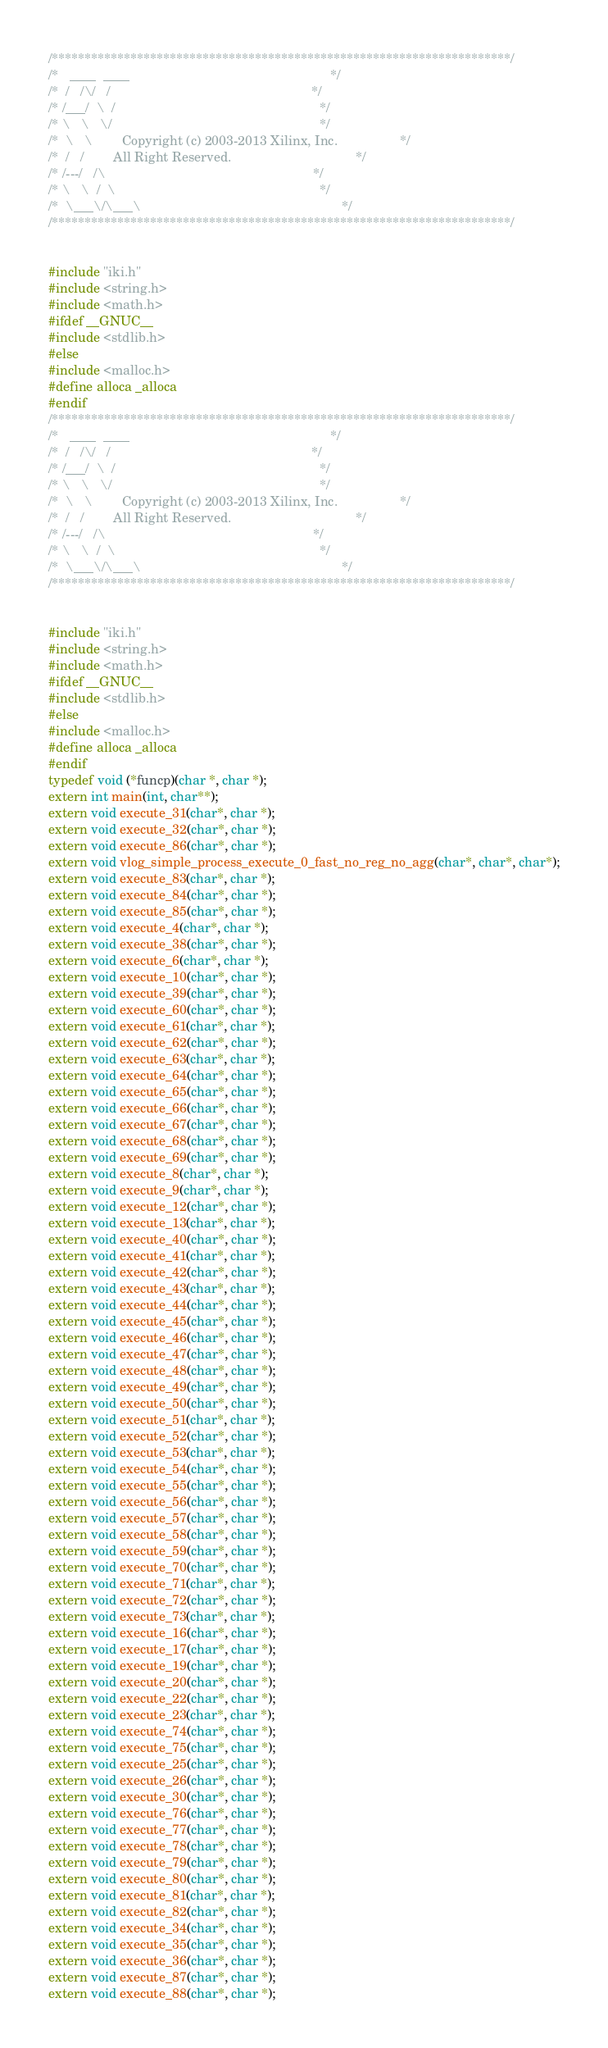<code> <loc_0><loc_0><loc_500><loc_500><_C_>/**********************************************************************/
/*   ____  ____                                                       */
/*  /   /\/   /                                                       */
/* /___/  \  /                                                        */
/* \   \   \/                                                         */
/*  \   \        Copyright (c) 2003-2013 Xilinx, Inc.                 */
/*  /   /        All Right Reserved.                                  */
/* /---/   /\                                                         */
/* \   \  /  \                                                        */
/*  \___\/\___\                                                       */
/**********************************************************************/


#include "iki.h"
#include <string.h>
#include <math.h>
#ifdef __GNUC__
#include <stdlib.h>
#else
#include <malloc.h>
#define alloca _alloca
#endif
/**********************************************************************/
/*   ____  ____                                                       */
/*  /   /\/   /                                                       */
/* /___/  \  /                                                        */
/* \   \   \/                                                         */
/*  \   \        Copyright (c) 2003-2013 Xilinx, Inc.                 */
/*  /   /        All Right Reserved.                                  */
/* /---/   /\                                                         */
/* \   \  /  \                                                        */
/*  \___\/\___\                                                       */
/**********************************************************************/


#include "iki.h"
#include <string.h>
#include <math.h>
#ifdef __GNUC__
#include <stdlib.h>
#else
#include <malloc.h>
#define alloca _alloca
#endif
typedef void (*funcp)(char *, char *);
extern int main(int, char**);
extern void execute_31(char*, char *);
extern void execute_32(char*, char *);
extern void execute_86(char*, char *);
extern void vlog_simple_process_execute_0_fast_no_reg_no_agg(char*, char*, char*);
extern void execute_83(char*, char *);
extern void execute_84(char*, char *);
extern void execute_85(char*, char *);
extern void execute_4(char*, char *);
extern void execute_38(char*, char *);
extern void execute_6(char*, char *);
extern void execute_10(char*, char *);
extern void execute_39(char*, char *);
extern void execute_60(char*, char *);
extern void execute_61(char*, char *);
extern void execute_62(char*, char *);
extern void execute_63(char*, char *);
extern void execute_64(char*, char *);
extern void execute_65(char*, char *);
extern void execute_66(char*, char *);
extern void execute_67(char*, char *);
extern void execute_68(char*, char *);
extern void execute_69(char*, char *);
extern void execute_8(char*, char *);
extern void execute_9(char*, char *);
extern void execute_12(char*, char *);
extern void execute_13(char*, char *);
extern void execute_40(char*, char *);
extern void execute_41(char*, char *);
extern void execute_42(char*, char *);
extern void execute_43(char*, char *);
extern void execute_44(char*, char *);
extern void execute_45(char*, char *);
extern void execute_46(char*, char *);
extern void execute_47(char*, char *);
extern void execute_48(char*, char *);
extern void execute_49(char*, char *);
extern void execute_50(char*, char *);
extern void execute_51(char*, char *);
extern void execute_52(char*, char *);
extern void execute_53(char*, char *);
extern void execute_54(char*, char *);
extern void execute_55(char*, char *);
extern void execute_56(char*, char *);
extern void execute_57(char*, char *);
extern void execute_58(char*, char *);
extern void execute_59(char*, char *);
extern void execute_70(char*, char *);
extern void execute_71(char*, char *);
extern void execute_72(char*, char *);
extern void execute_73(char*, char *);
extern void execute_16(char*, char *);
extern void execute_17(char*, char *);
extern void execute_19(char*, char *);
extern void execute_20(char*, char *);
extern void execute_22(char*, char *);
extern void execute_23(char*, char *);
extern void execute_74(char*, char *);
extern void execute_75(char*, char *);
extern void execute_25(char*, char *);
extern void execute_26(char*, char *);
extern void execute_30(char*, char *);
extern void execute_76(char*, char *);
extern void execute_77(char*, char *);
extern void execute_78(char*, char *);
extern void execute_79(char*, char *);
extern void execute_80(char*, char *);
extern void execute_81(char*, char *);
extern void execute_82(char*, char *);
extern void execute_34(char*, char *);
extern void execute_35(char*, char *);
extern void execute_36(char*, char *);
extern void execute_87(char*, char *);
extern void execute_88(char*, char *);</code> 